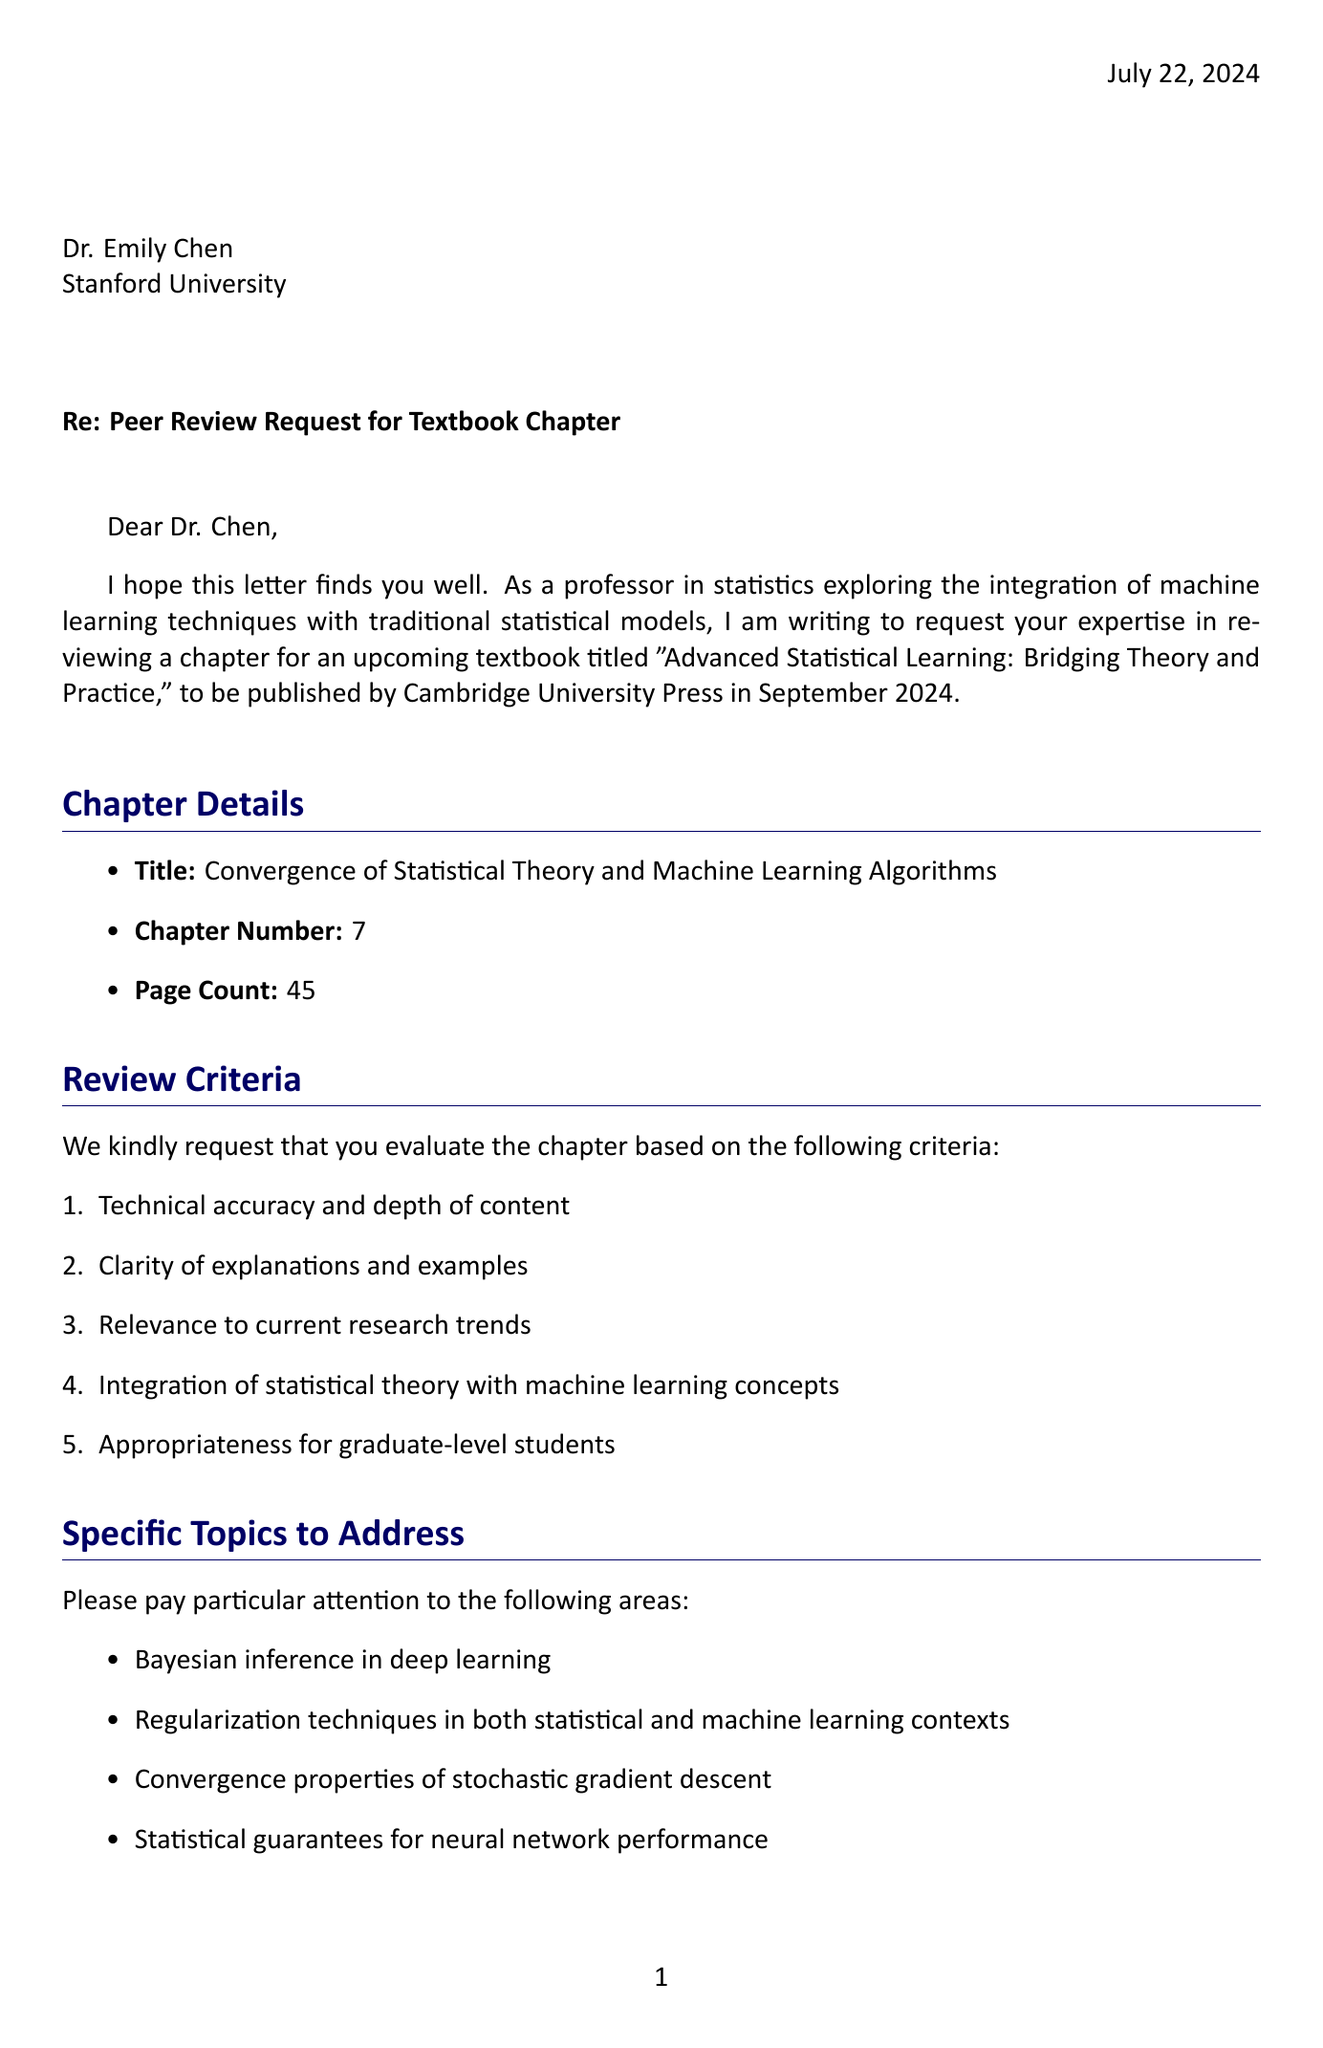What is the title of the textbook? The title of the textbook is specified in the document, which is "Advanced Statistical Learning: Bridging Theory and Practice."
Answer: Advanced Statistical Learning: Bridging Theory and Practice Who is the peer reviewer? The document identifies the peer reviewer as Dr. Emily Chen.
Answer: Dr. Emily Chen What is the total page count of the chapter? The page count of the chapter is mentioned in the document, which states it is 45 pages.
Answer: 45 What are the supplementary datasets listed? The document provides two supplementary datasets, which are listed in the materials section.
Answer: UCI Machine Learning Repository - Adult Income dataset, MNIST handwritten digit database What is the review deadline? The document specifies the deadline for the review, which is stated clearly as August 15, 2023.
Answer: August 15, 2023 How many specific topics are requested to address in the review? The document lists the specific topics to address as four distinct areas related to the chapter content.
Answer: Four What is the author's research focus? The document describes the author's research focus as the integration of machine learning techniques with traditional statistical models.
Answer: Integration of machine learning techniques with traditional statistical models What event is mentioned related to the author's presentation? The document states that the author will be presenting at an event, which is listed in the text.
Answer: Joint Statistical Meetings (JSM) 2023 What criteria is used for evaluating the chapter? The document outlines several criteria for evaluation, mentioning technical accuracy, clarity, relevance, and more.
Answer: Technical accuracy and depth of content, clarity of explanations and examples, relevance to current research trends, integration of statistical theory with machine learning concepts, appropriateness for graduate-level students 